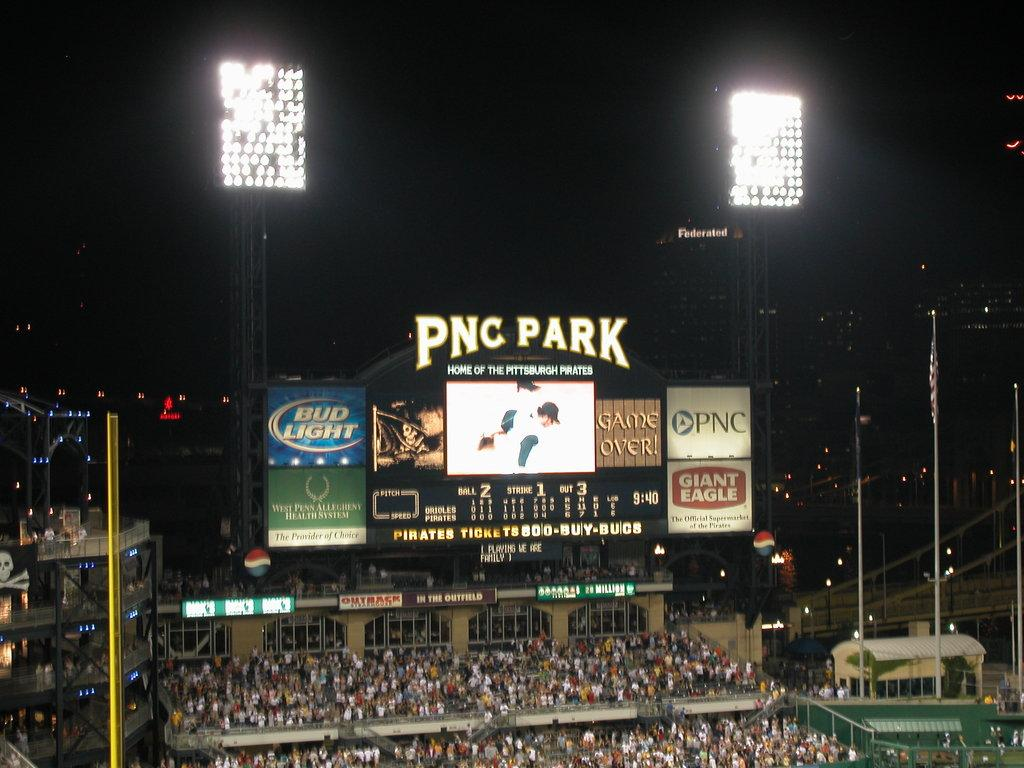<image>
Provide a brief description of the given image. The blue ad on the sign is for Bud Light 